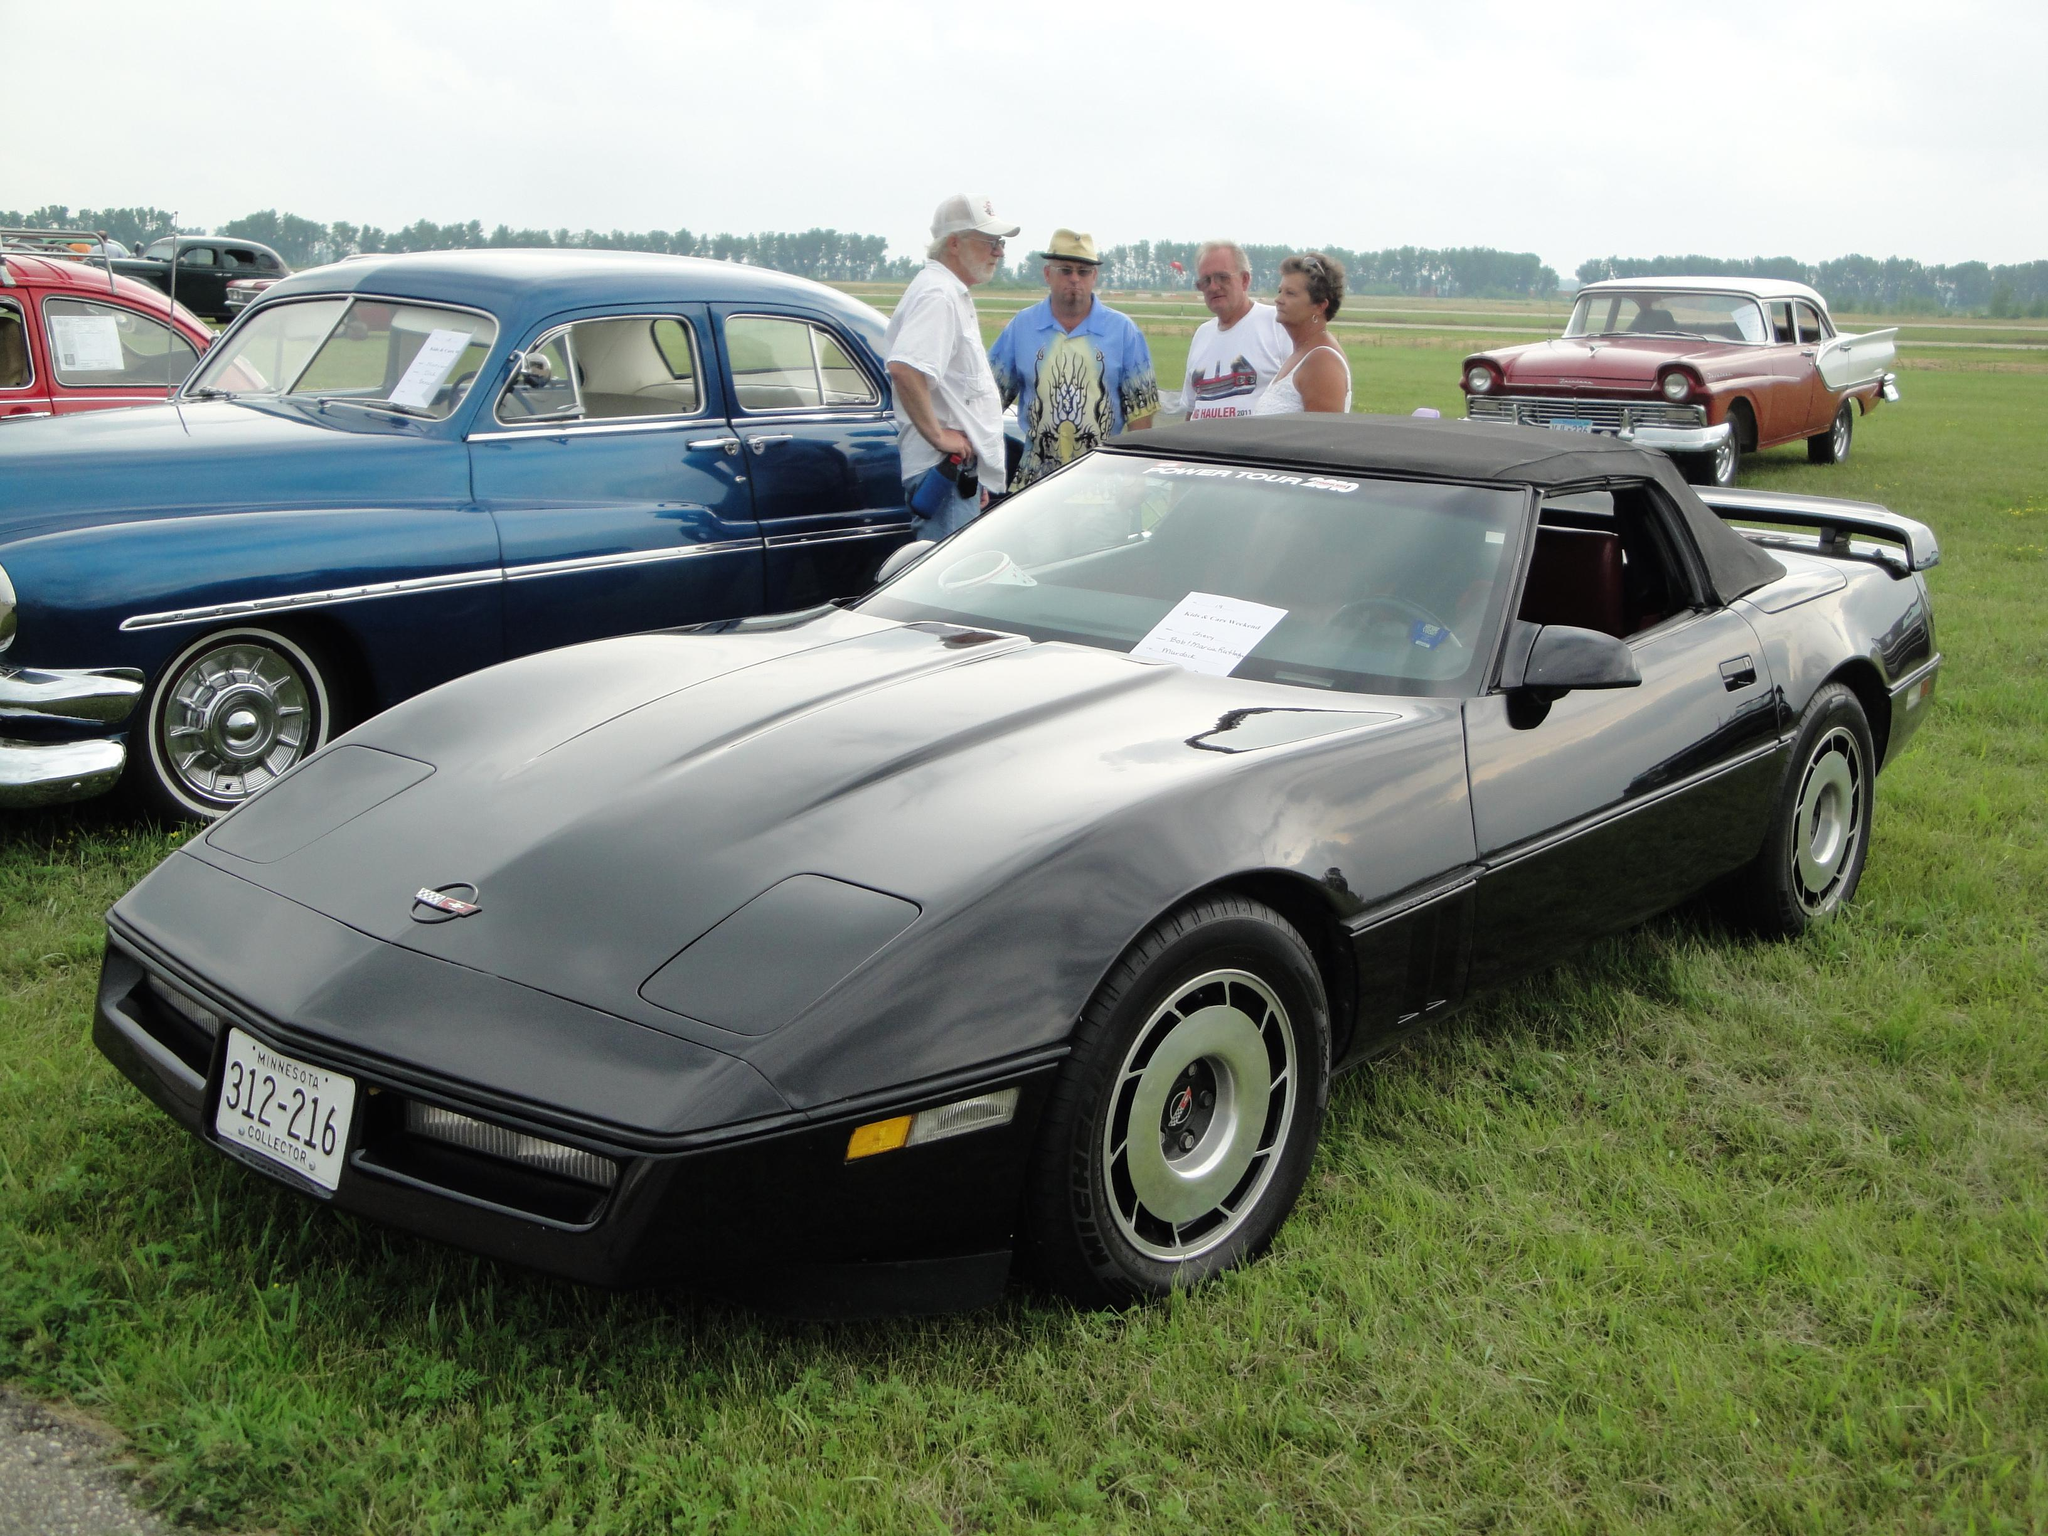What types of objects can be seen in the image? There are vehicles in the image. Can you describe the appearance of the vehicles? The vehicles are in different colors. What else is present in the image besides the vehicles? There are persons on the ground and trees in the background of the image. What is the ground made of in the image? The ground has grass on it. What can be seen in the sky in the image? There are clouds in the sky. What type of balloon is being used by the persons on the ground in the image? There is no balloon present in the image; the persons on the ground are not using any balloons. 